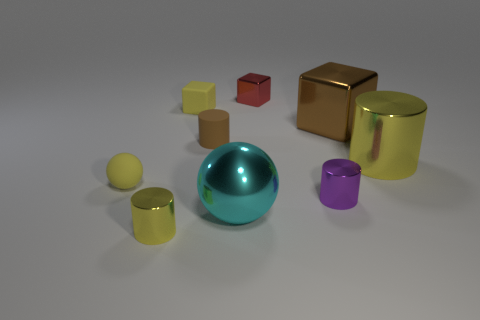Are there any other metallic things that have the same shape as the red metallic object?
Keep it short and to the point. Yes. What is the red thing made of?
Ensure brevity in your answer.  Metal. Are there any yellow objects in front of the large yellow metallic cylinder?
Your answer should be very brief. Yes. What number of brown things are on the left side of the tiny cylinder that is behind the yellow rubber ball?
Your answer should be very brief. 0. What material is the red thing that is the same size as the purple thing?
Keep it short and to the point. Metal. What number of other objects are the same material as the large yellow object?
Offer a very short reply. 5. There is a brown metal cube; how many big yellow metallic cylinders are behind it?
Give a very brief answer. 0. What number of blocks are small yellow matte things or small red metallic things?
Your response must be concise. 2. How big is the rubber object that is both in front of the brown cube and left of the tiny brown matte cylinder?
Make the answer very short. Small. What number of other things are the same color as the big shiny ball?
Give a very brief answer. 0. 